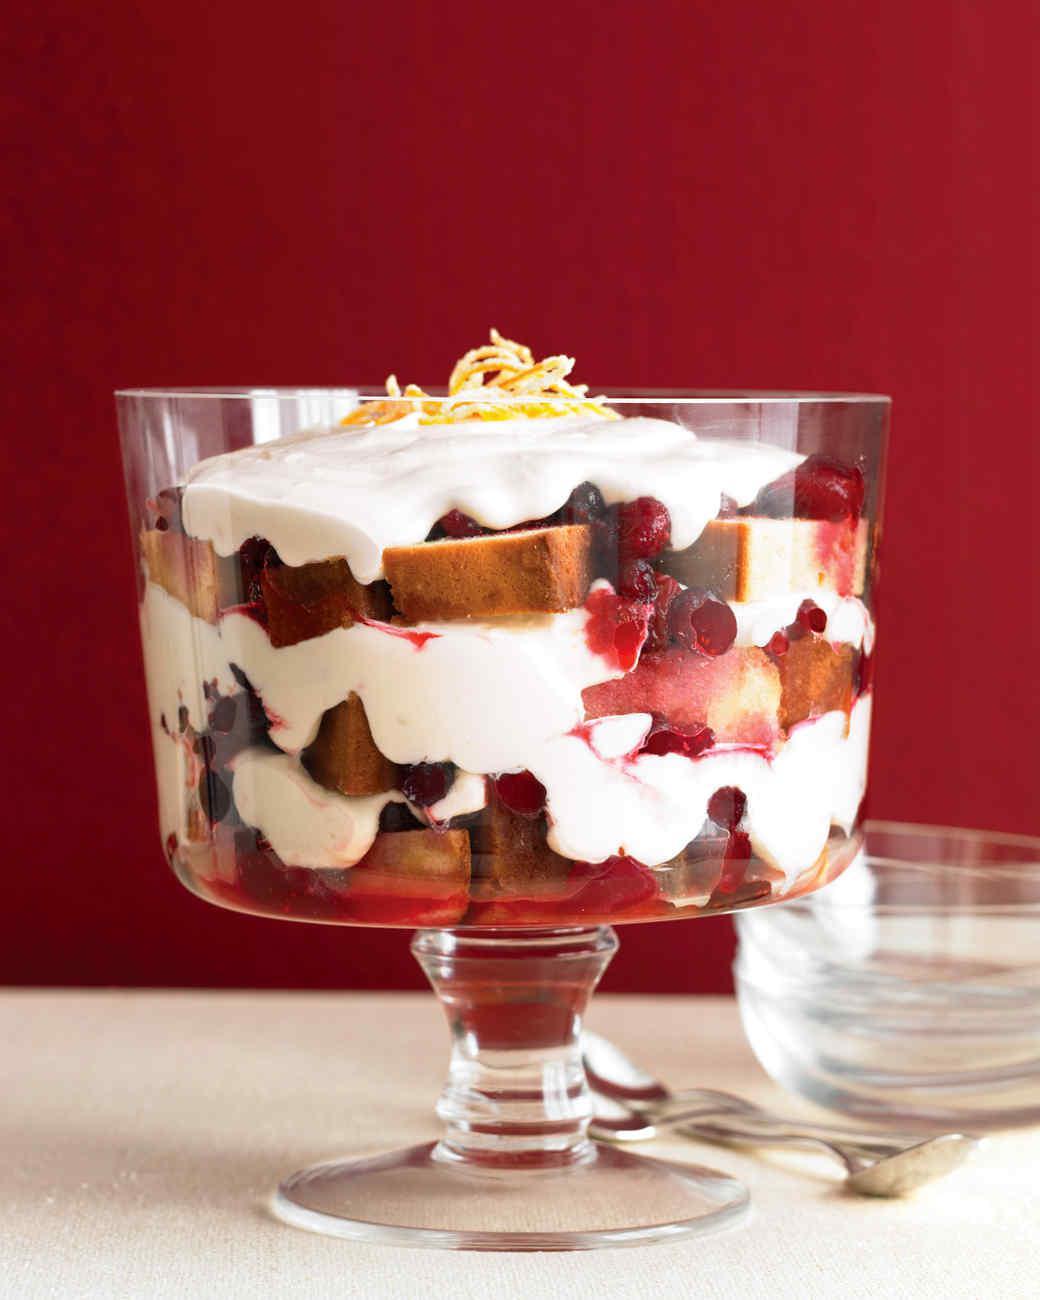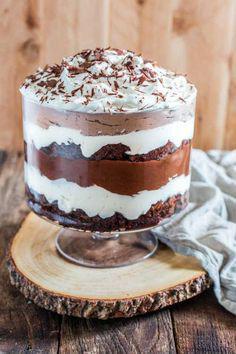The first image is the image on the left, the second image is the image on the right. Evaluate the accuracy of this statement regarding the images: "An image shows a group of layered desserts topped with brown whipped cream and sprinkles.". Is it true? Answer yes or no. No. The first image is the image on the left, the second image is the image on the right. Evaluate the accuracy of this statement regarding the images: "There are three cups of dessert in the image on the left.". Is it true? Answer yes or no. No. 